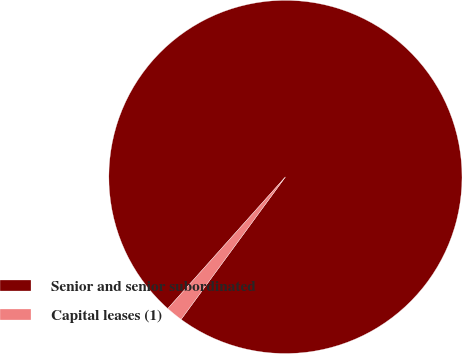Convert chart to OTSL. <chart><loc_0><loc_0><loc_500><loc_500><pie_chart><fcel>Senior and senior subordinated<fcel>Capital leases (1)<nl><fcel>98.45%<fcel>1.55%<nl></chart> 